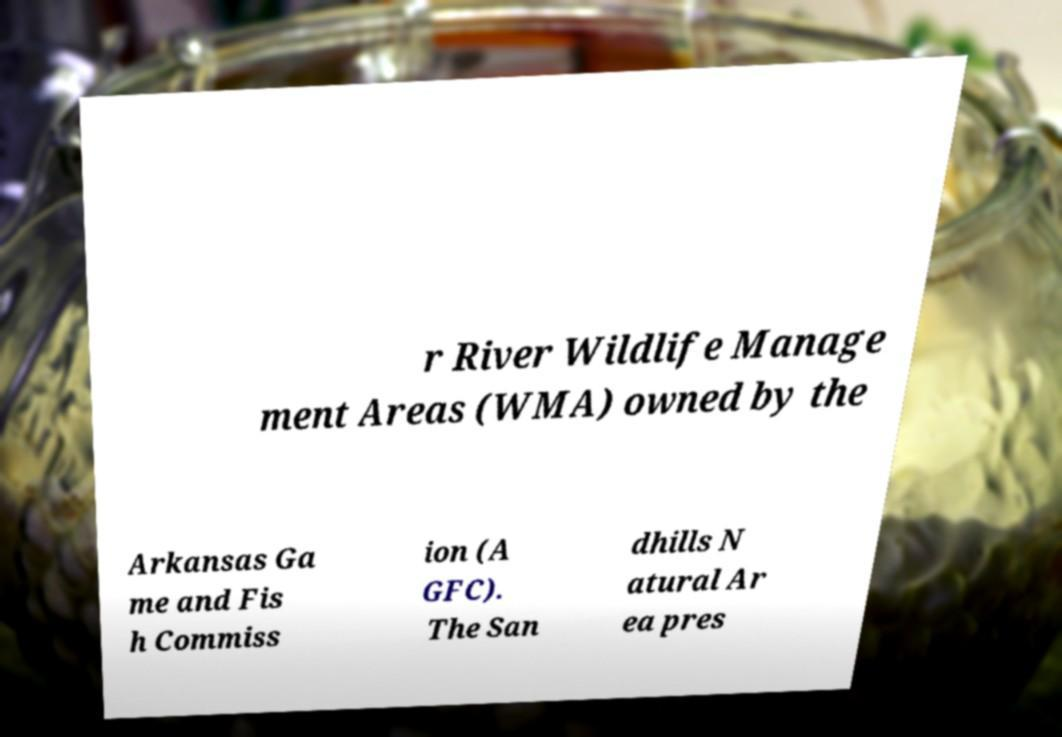What messages or text are displayed in this image? I need them in a readable, typed format. r River Wildlife Manage ment Areas (WMA) owned by the Arkansas Ga me and Fis h Commiss ion (A GFC). The San dhills N atural Ar ea pres 